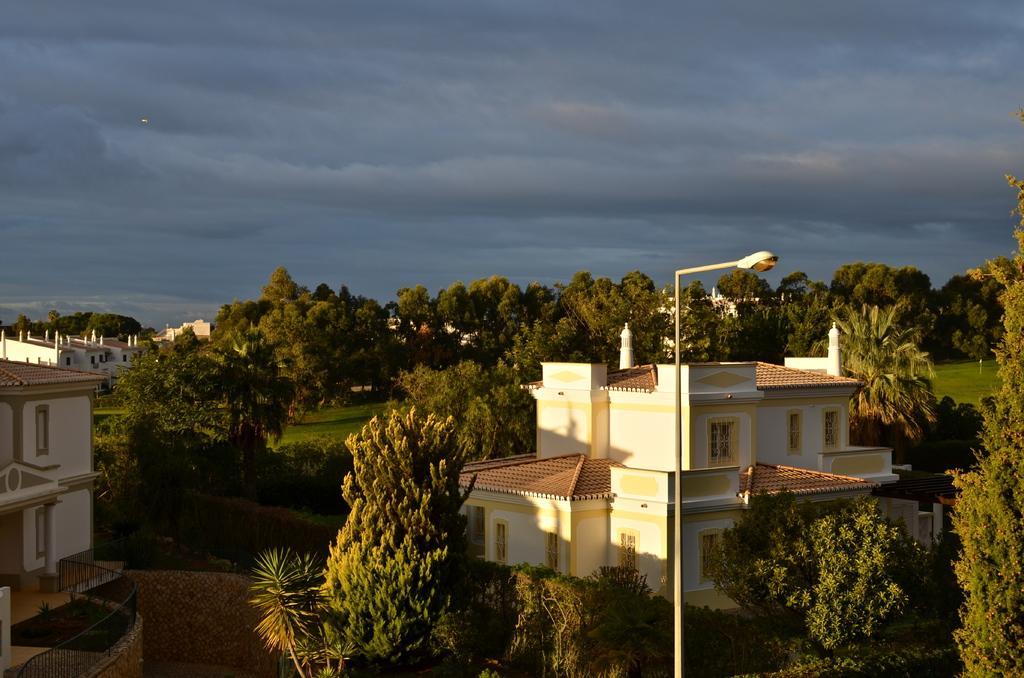Describe this image in one or two sentences. On the left side, there is a building having windows and roof and there's grass on the ground. On the right side, there are trees, a light attached to the pole and there is a building which is having glass windows and roof. In the background, there are trees, buildings and grass on the ground and there are clouds in the sky. 